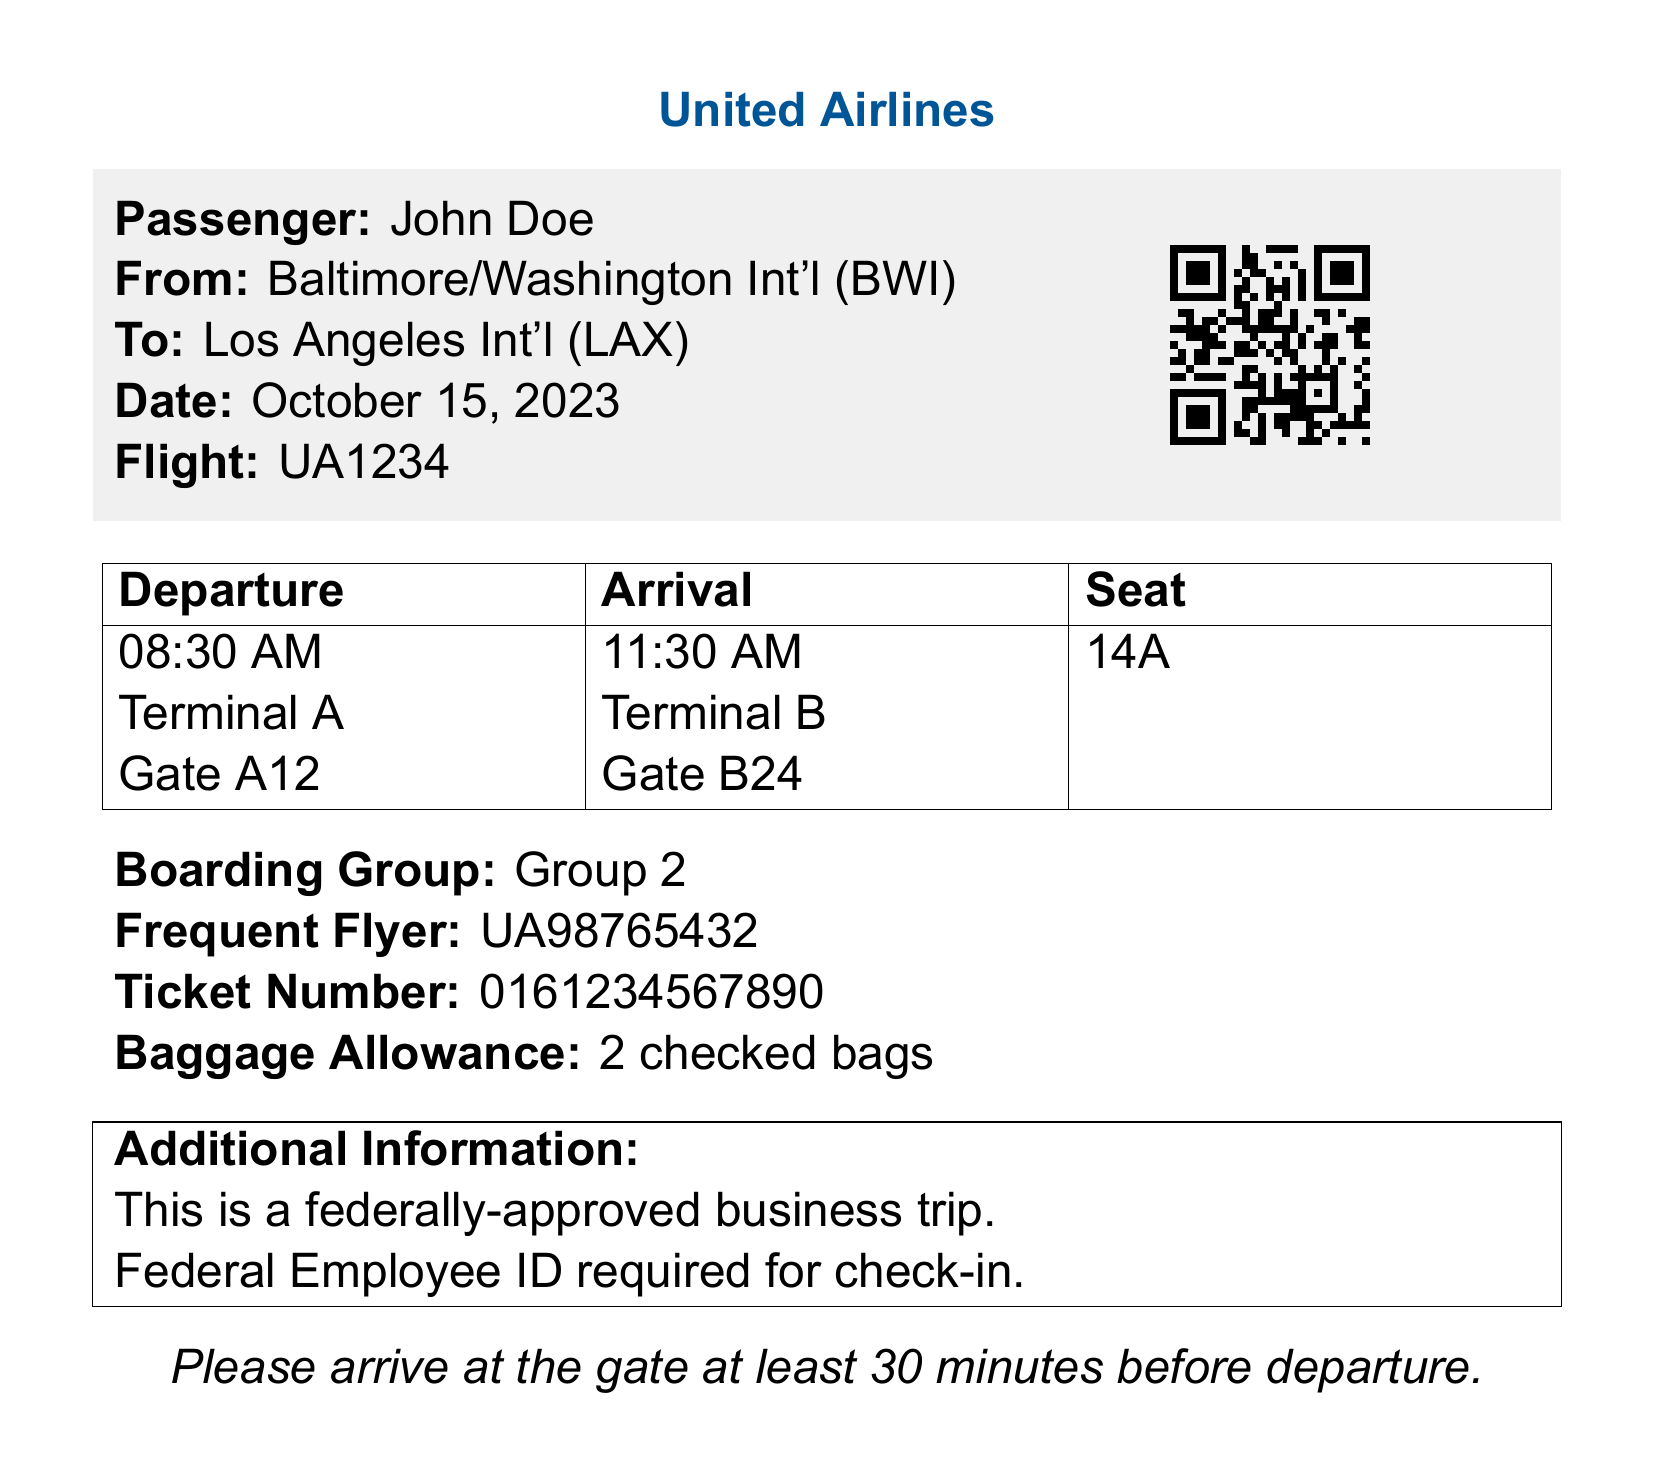What is the passenger's name? The passenger's name is listed at the top of the document under "Passenger."
Answer: John Doe What is the flight number? The flight number is specified in the flight details section of the document.
Answer: UA1234 What time does the flight depart? The departure time is found in the flight schedule table.
Answer: 08:30 AM What is the seat assignment? The seat assignment is indicated in the schedule table as well.
Answer: 14A Which terminal does the flight depart from? The terminal information is mentioned in the schedule table.
Answer: Terminal A What is the boarding group? The boarding group is prominently stated in the ticket details section.
Answer: Group 2 What is the baggage allowance? The baggage allowance is specified towards the end of the document.
Answer: 2 checked bags What time does the flight arrive? The arrival time is included in the schedule table of the document.
Answer: 11:30 AM What is required for check-in? The additional information section states an important requirement for check-in.
Answer: Federal Employee ID 